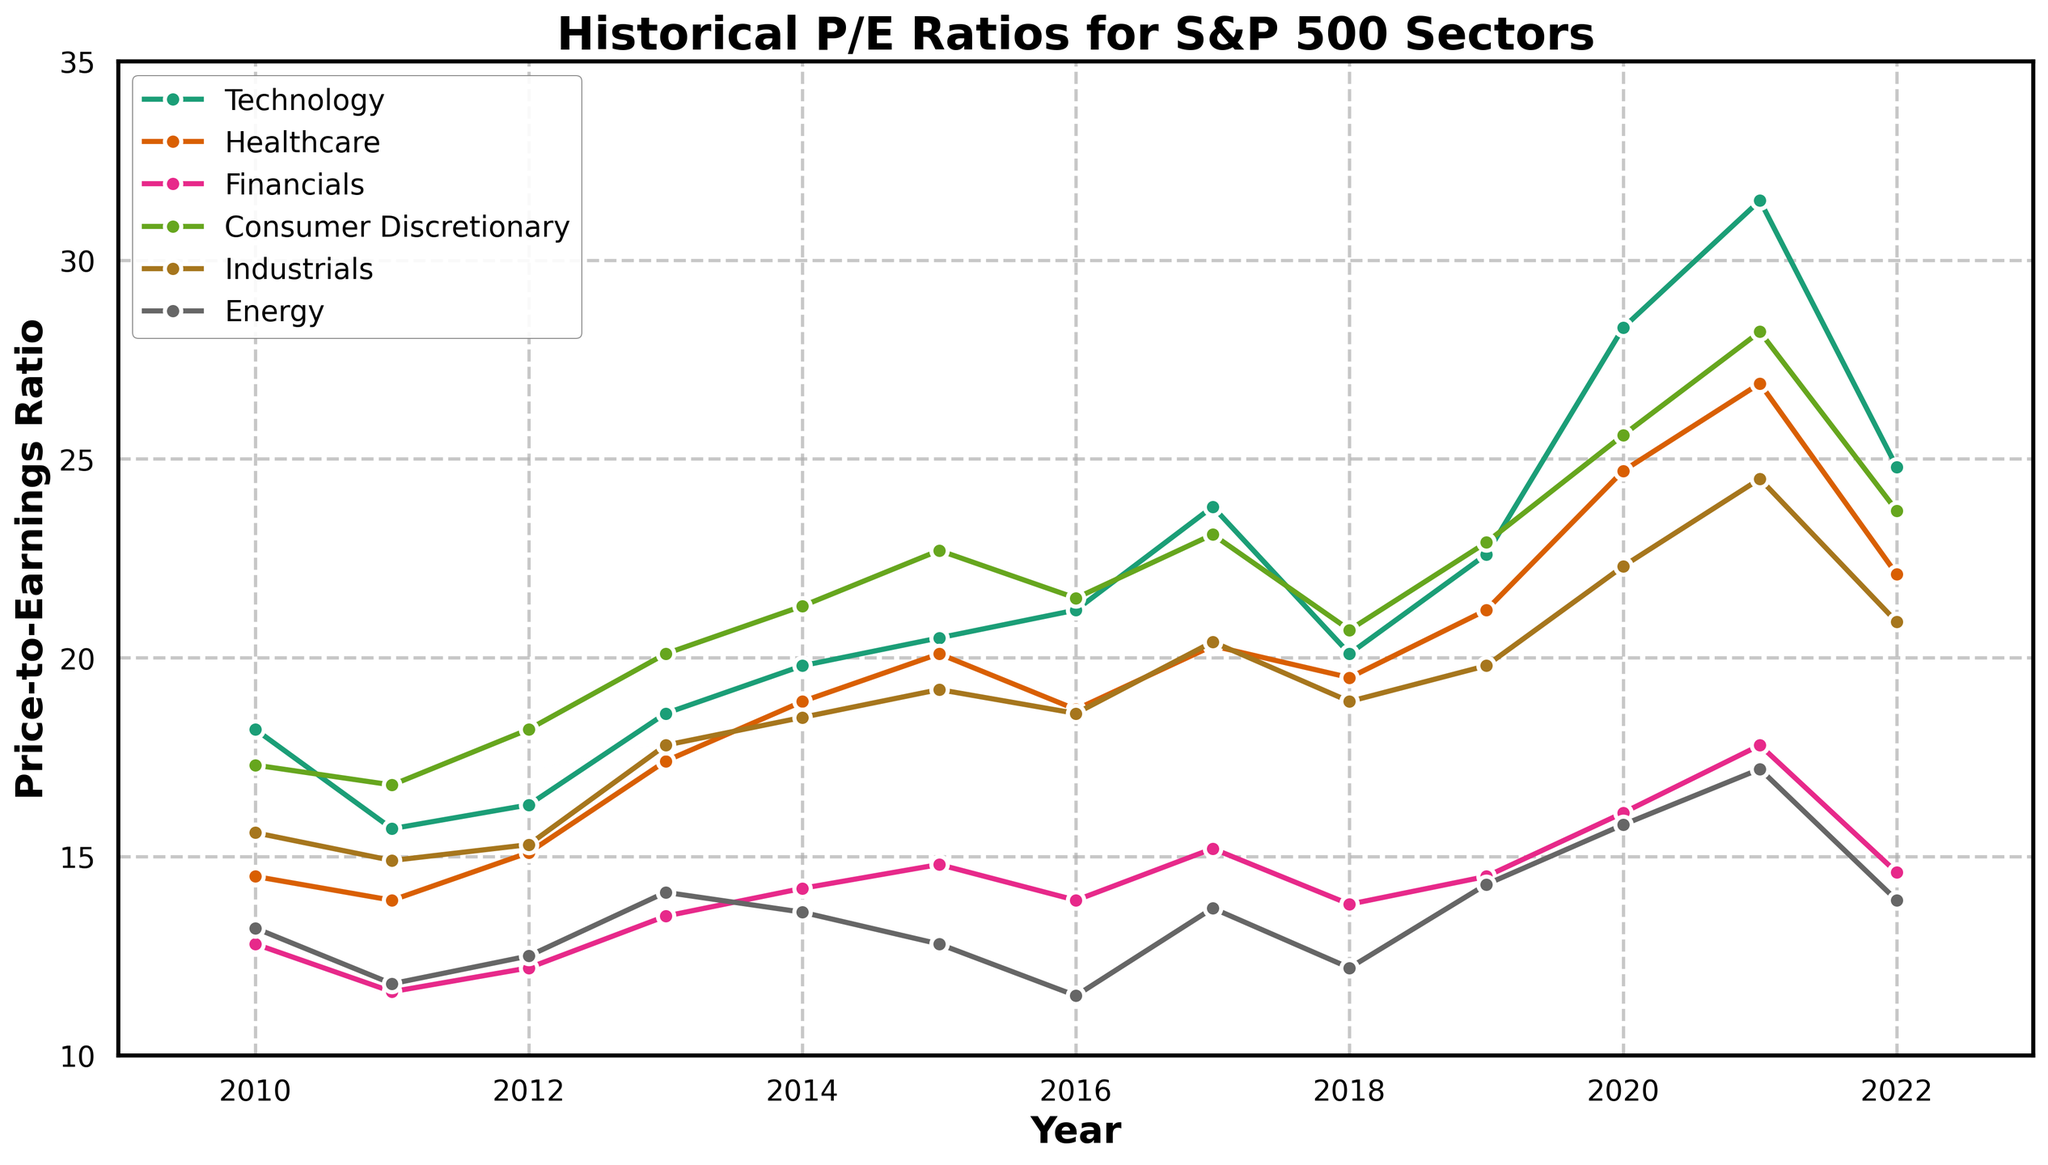Which sector had the highest P/E ratio in 2021? To determine this, observe the y-axis value for each sector in 2021. The series reaching the highest point indicates the sector with the highest P/E ratio. Here, it is the Technology sector.
Answer: Technology How did the Consumer Discretionary sector's P/E ratio change from 2019 to 2020? Examine the P/E values for Consumer Discretionary in 2019 and 2020. In 2019, it is 22.9, and in 2020, it increased to 25.6.
Answer: Increased Which sector experienced the largest increase in P/E ratio from 2019 to 2020? Calculate the increase by subtracting the 2019 value from the 2020 value for each sector. Technology increased by 5.7, Healthcare by 3.5, Financials by 1.6, Consumer Discretionary by 2.7, Industrials by 2.5, and Energy by 1.5. The largest increase is in Technology.
Answer: Technology In which year did the Energy sector have its lowest P/E ratio within the presented timeline? Scan the Energy sector's line on the plot to find the year with the lowest point. The lowest value, 11.5, is in 2016.
Answer: 2016 Compare the P/E ratio trends of Technology and Healthcare sectors from 2010 to 2022. Which sector had a more consistent increase? Observe both lines from 2010 to 2022. Technology shows a more consistent and steady upward trend, while Healthcare fluctuates more with increases and slight decreases.
Answer: Technology What was the overall trend of the Industrial sector's P/E ratio from 2010 to 2022? Follow the path of the Industrials line from 2010 to 2022. It generally trends upwards, despite some fluctuations.
Answer: Increasing From 2018 to 2019, which sector had the greatest decrease in P/E ratio? Calculate the difference between 2018 and 2019 values for each sector. Technology: 22.6 - 20.1 = 2.5 increase, Healthcare: 21.2 - 19.5 = 1.7 increase, Financials: 14.5 - 13.8 = 0.7 increase, Consumer Discretionary: 22.9 - 20.7 = 2.2 increase, Industrials: 19.8 - 18.9 = 0.9 increase, Energy: 14.3 - 12.2 = 2.1 increase. Since all are increases, there was no decrease.
Answer: None What was the P/E ratio of the Financials sector in 2016? Locate the Financials line at the year 2016. The P/E ratio value shown there is 13.9.
Answer: 13.9 In 2021, how did the P/E ratio of the Industrials sector compare to the Healthcare sector? Find the P/E ratio of Industrials and Healthcare in 2021. Industrials is 24.5 and Healthcare is 26.9. The Industrials sector had a lower P/E ratio compared to Healthcare in 2021.
Answer: Lower 